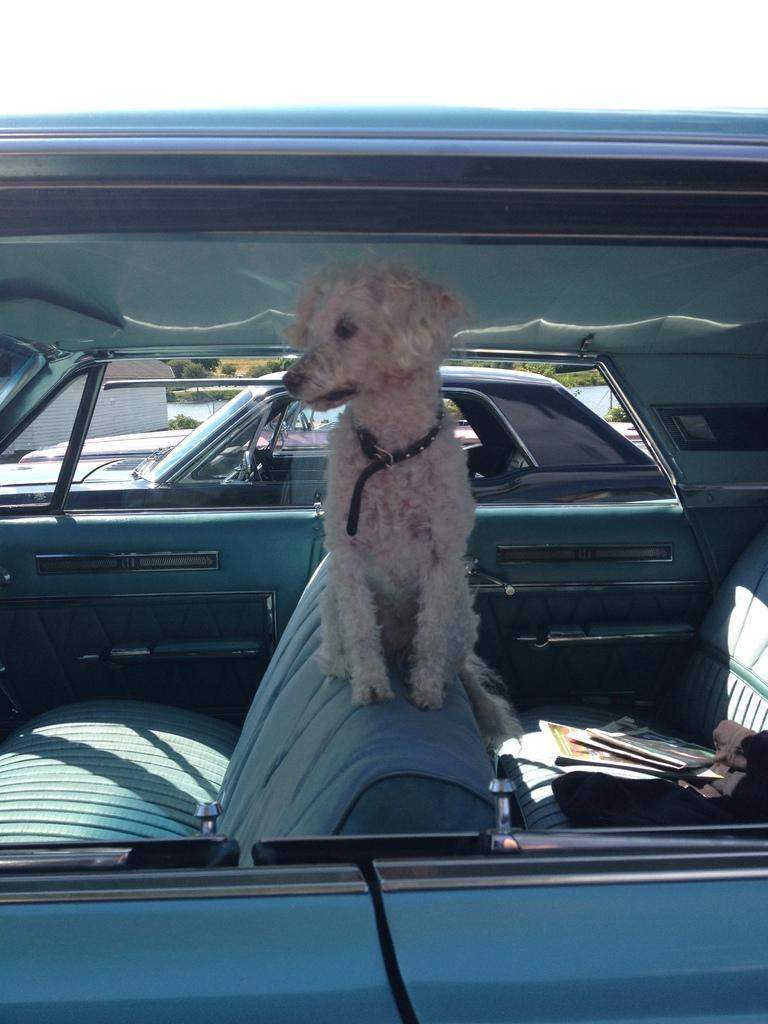What is the main subject of the image? There is a car in the image. What is the dog doing in the car? A dog is standing in the car. Where is the dog positioned in the car? The dog is positioned between the seats. Are there any other cars in the image? Yes, there is another car in the image. What is the condition of the second car? The second car is standing. Can you tell me how many eggs the dog is kicking in the car? There are no eggs present in the image, and the dog is not kicking anything. 